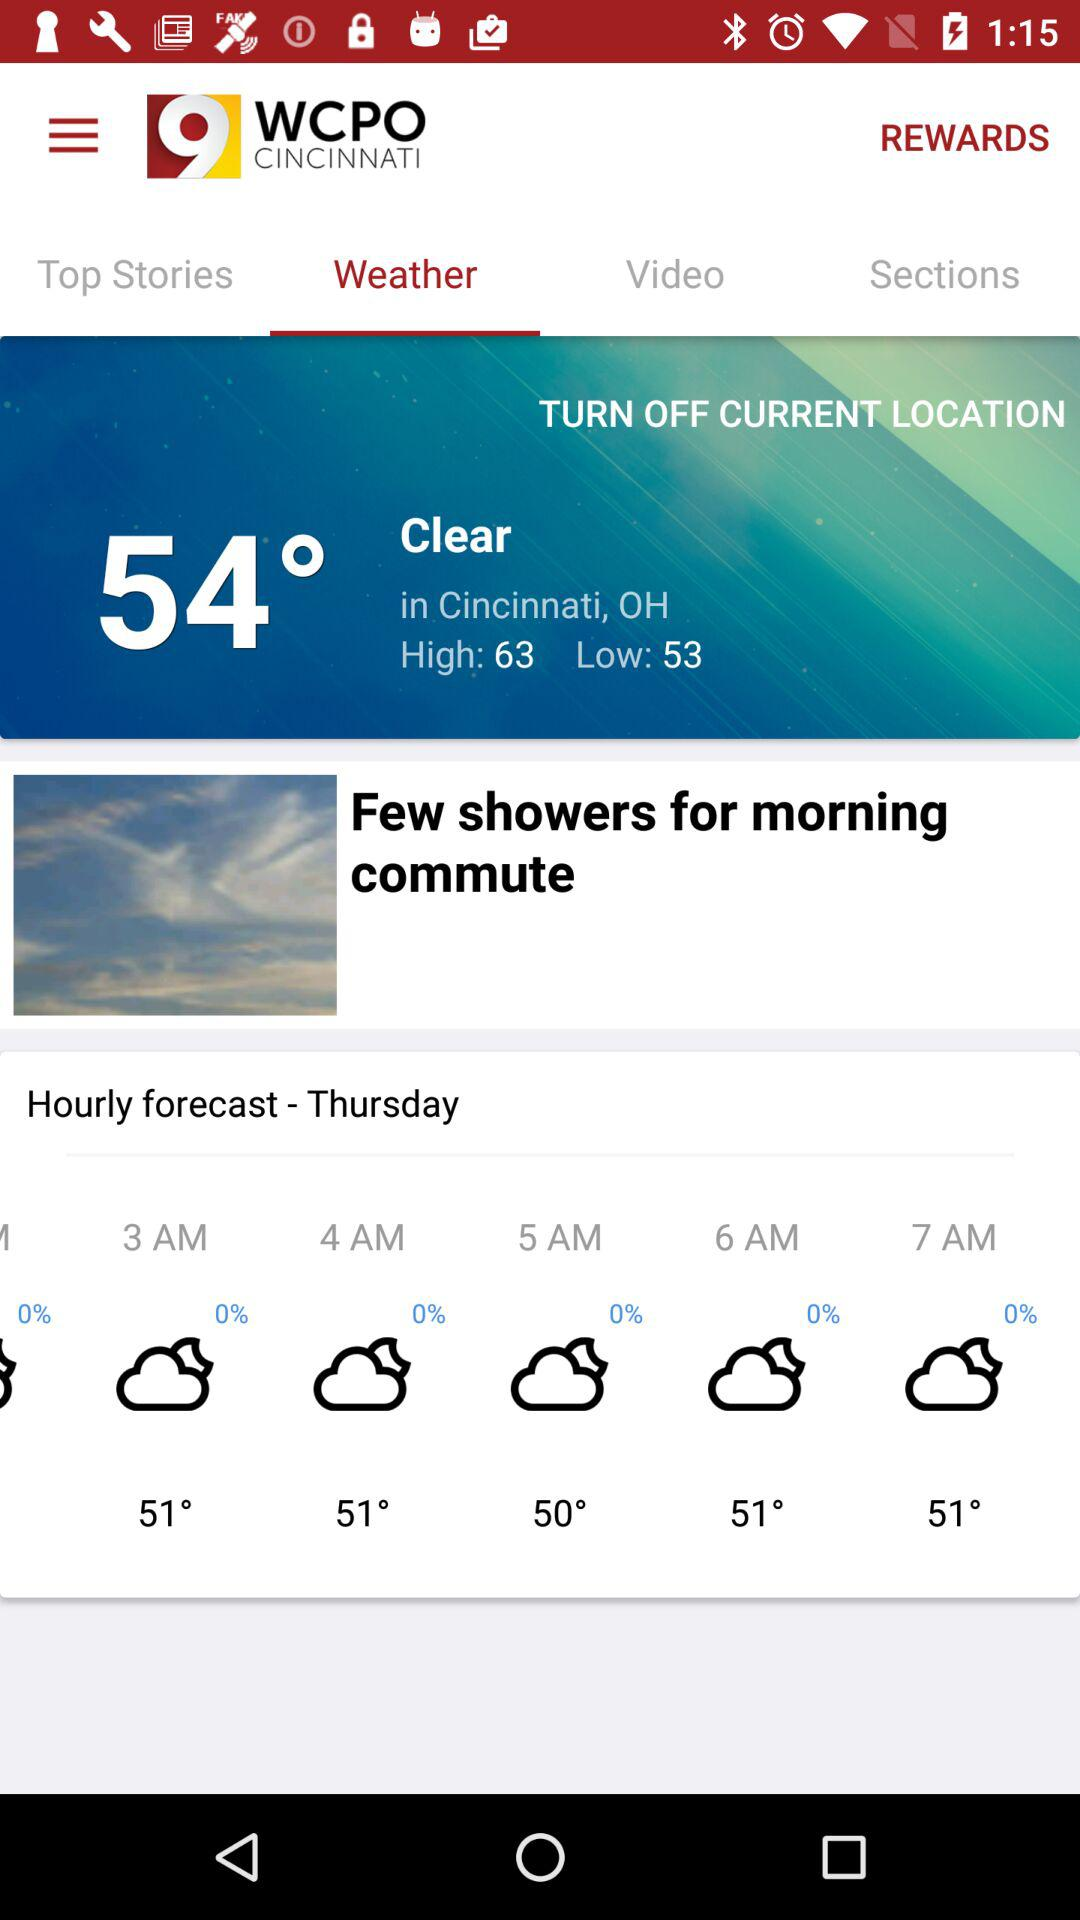How much rain will there be at 7 a.m. on Thursday? There will be 0% rain. 